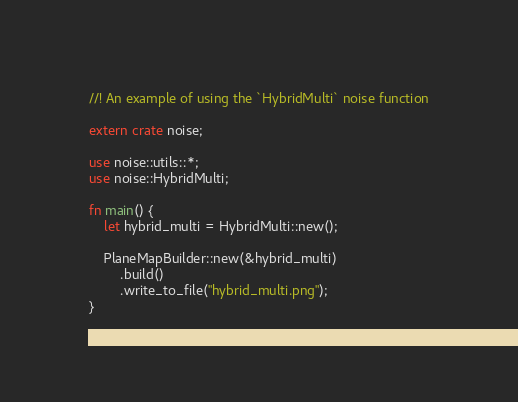<code> <loc_0><loc_0><loc_500><loc_500><_Rust_>//! An example of using the `HybridMulti` noise function

extern crate noise;

use noise::utils::*;
use noise::HybridMulti;

fn main() {
    let hybrid_multi = HybridMulti::new();

    PlaneMapBuilder::new(&hybrid_multi)
        .build()
        .write_to_file("hybrid_multi.png");
}
</code> 